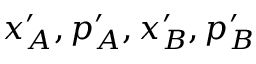Convert formula to latex. <formula><loc_0><loc_0><loc_500><loc_500>x _ { A } ^ { \prime } , p _ { A } ^ { \prime } , x _ { B } ^ { \prime } , p _ { B } ^ { \prime }</formula> 